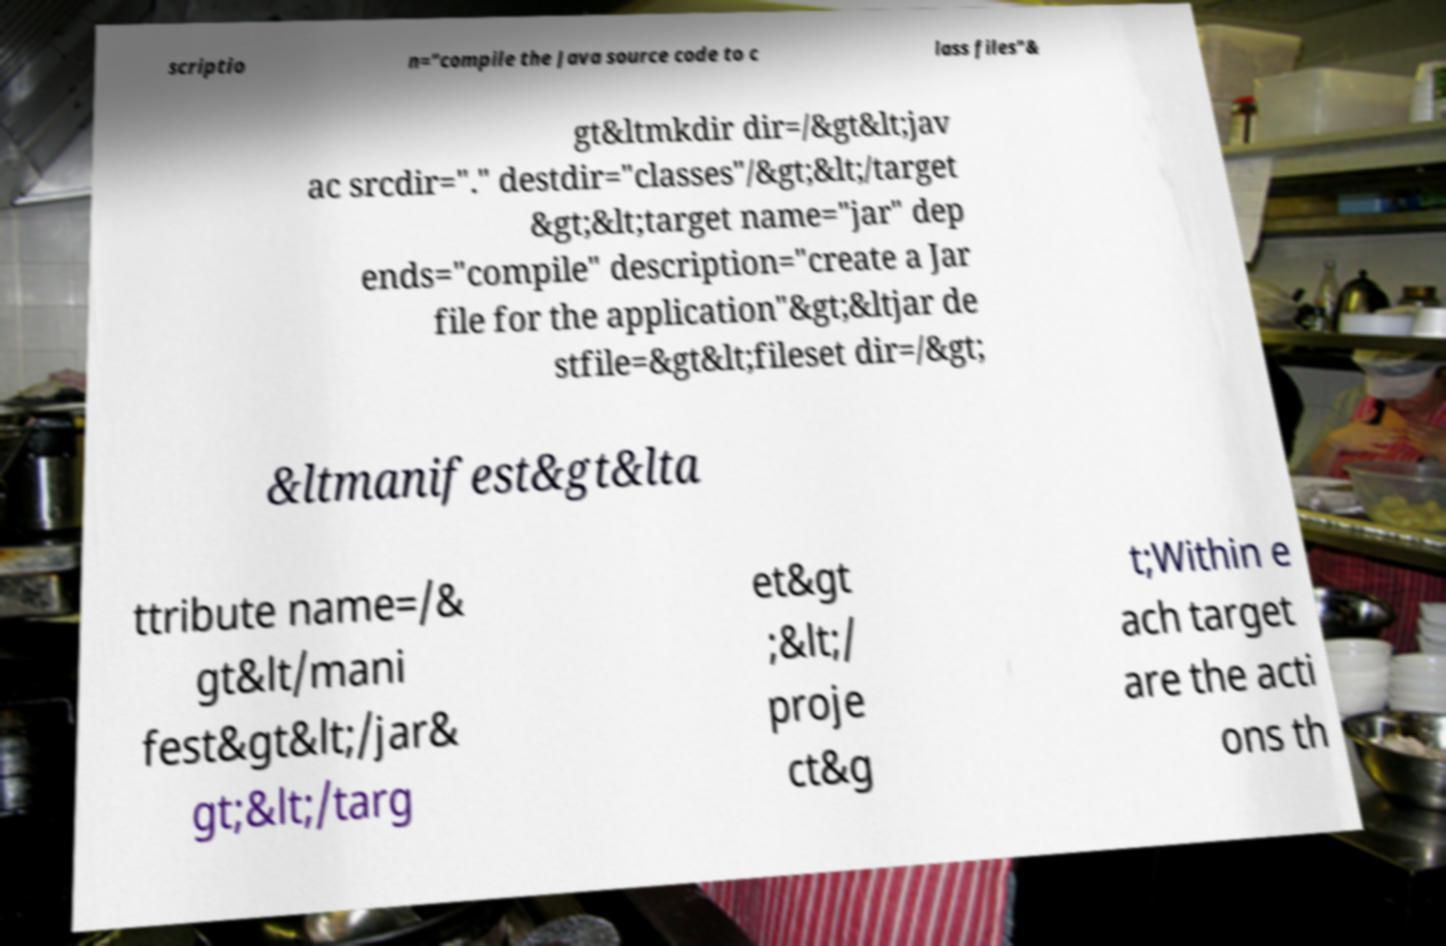Please read and relay the text visible in this image. What does it say? scriptio n="compile the Java source code to c lass files"& gt&ltmkdir dir=/&gt&lt;jav ac srcdir="." destdir="classes"/&gt;&lt;/target &gt;&lt;target name="jar" dep ends="compile" description="create a Jar file for the application"&gt;&ltjar de stfile=&gt&lt;fileset dir=/&gt; &ltmanifest&gt&lta ttribute name=/& gt&lt/mani fest&gt&lt;/jar& gt;&lt;/targ et&gt ;&lt;/ proje ct&g t;Within e ach target are the acti ons th 